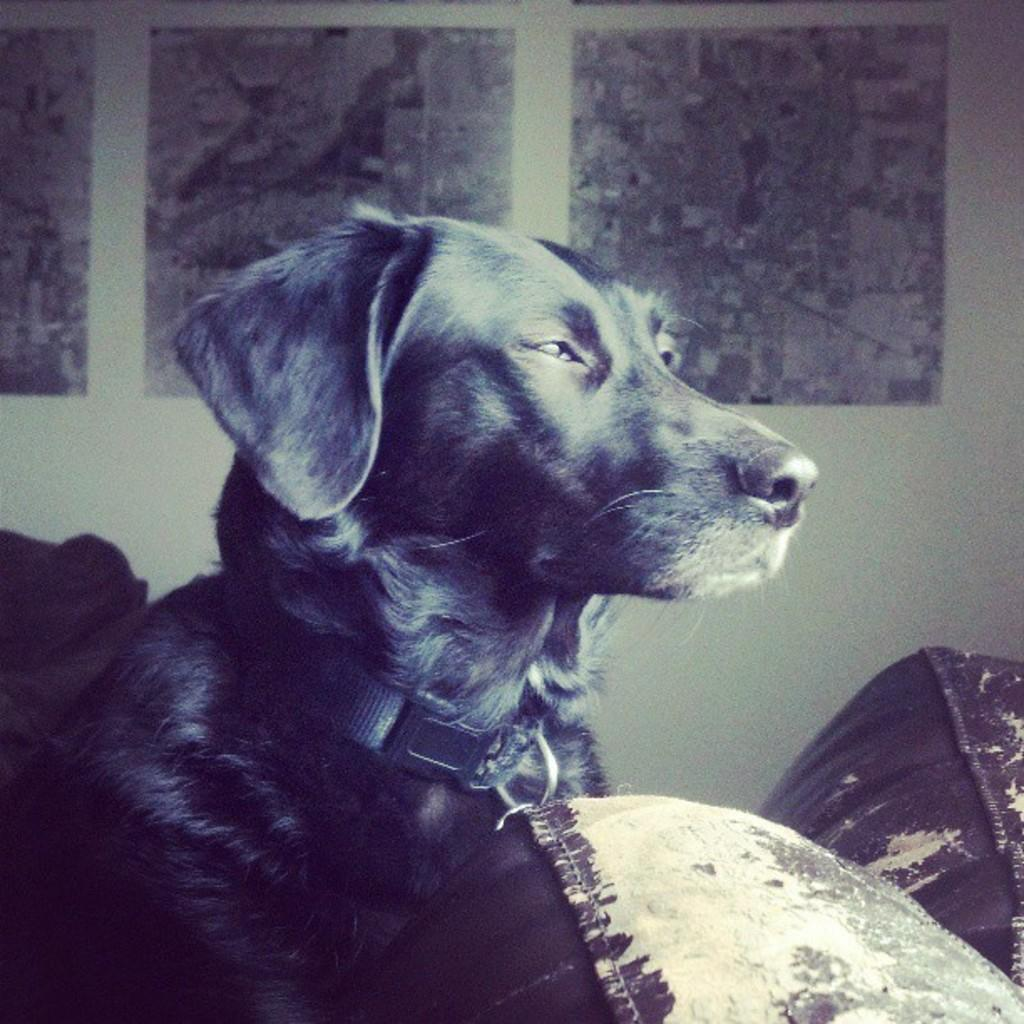What type of animal is in the image? There is a dog in the image. What is behind the dog in the image? There is a wall behind the dog. What can be seen on the wall in the image? There are posters on the wall. What type of heat source is present in the image? There is: There is no heat source present in the image; it only features a dog, a wall, and posters. 